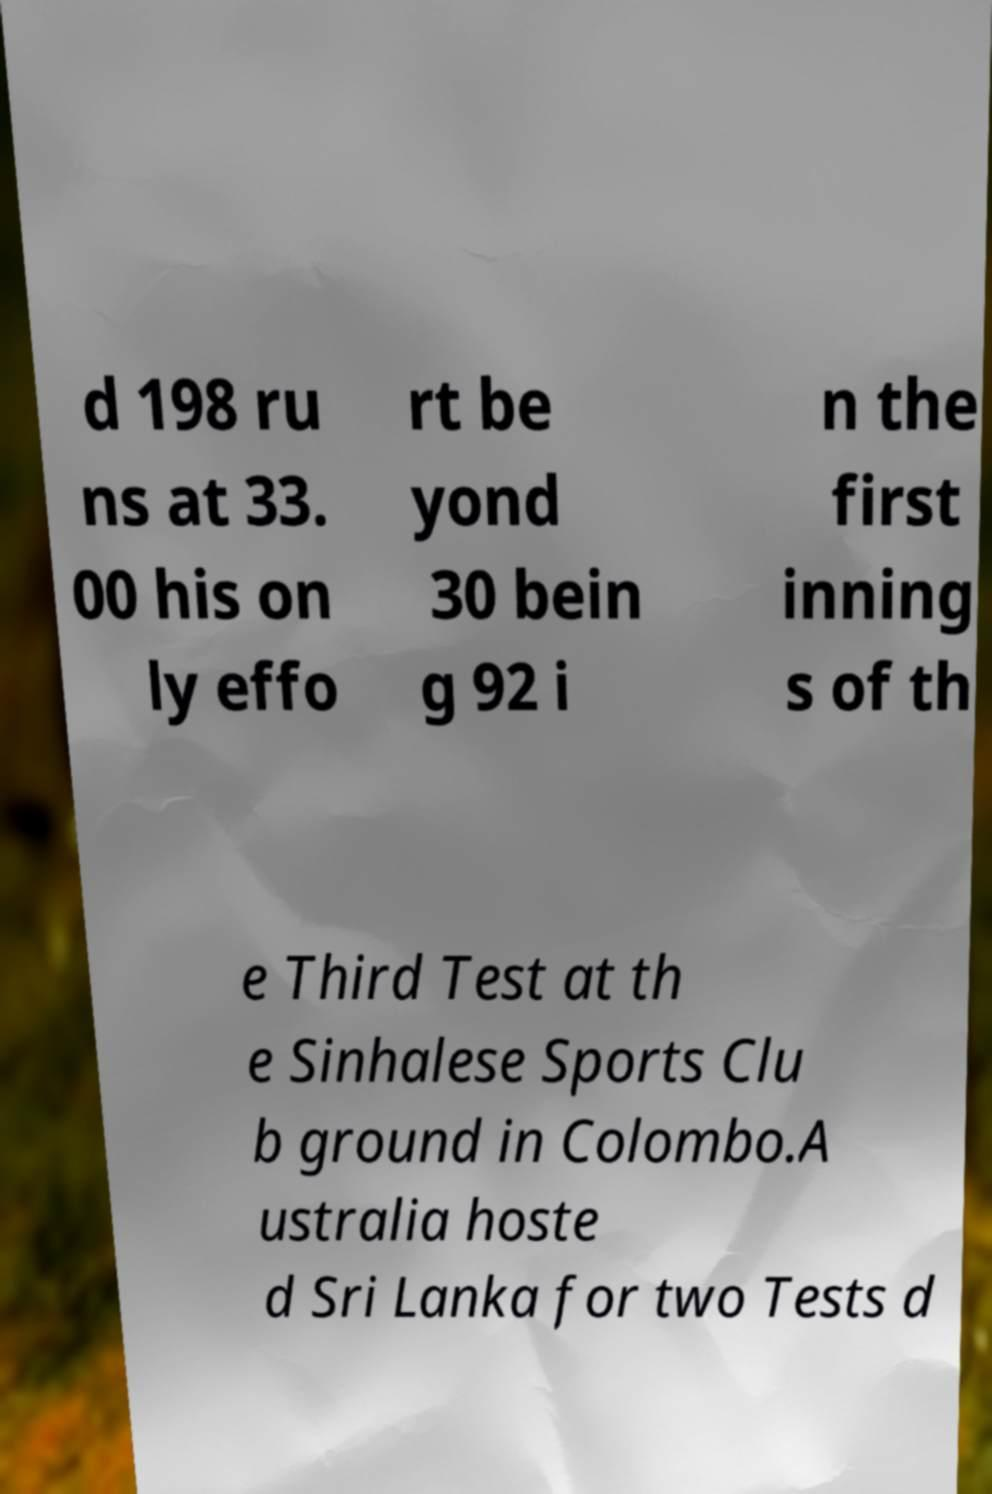There's text embedded in this image that I need extracted. Can you transcribe it verbatim? d 198 ru ns at 33. 00 his on ly effo rt be yond 30 bein g 92 i n the first inning s of th e Third Test at th e Sinhalese Sports Clu b ground in Colombo.A ustralia hoste d Sri Lanka for two Tests d 